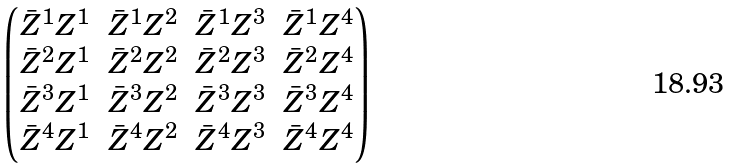Convert formula to latex. <formula><loc_0><loc_0><loc_500><loc_500>\begin{pmatrix} \bar { Z } ^ { 1 } Z ^ { 1 } & \bar { Z } ^ { 1 } Z ^ { 2 } & \bar { Z } ^ { 1 } Z ^ { 3 } & \bar { Z } ^ { 1 } Z ^ { 4 } \\ \bar { Z } ^ { 2 } Z ^ { 1 } & \bar { Z } ^ { 2 } Z ^ { 2 } & \bar { Z } ^ { 2 } Z ^ { 3 } & \bar { Z } ^ { 2 } Z ^ { 4 } \\ \bar { Z } ^ { 3 } Z ^ { 1 } & \bar { Z } ^ { 3 } Z ^ { 2 } & \bar { Z } ^ { 3 } Z ^ { 3 } & \bar { Z } ^ { 3 } Z ^ { 4 } \\ \bar { Z } ^ { 4 } Z ^ { 1 } & \bar { Z } ^ { 4 } Z ^ { 2 } & \bar { Z } ^ { 4 } Z ^ { 3 } & \bar { Z } ^ { 4 } Z ^ { 4 } \end{pmatrix}</formula> 